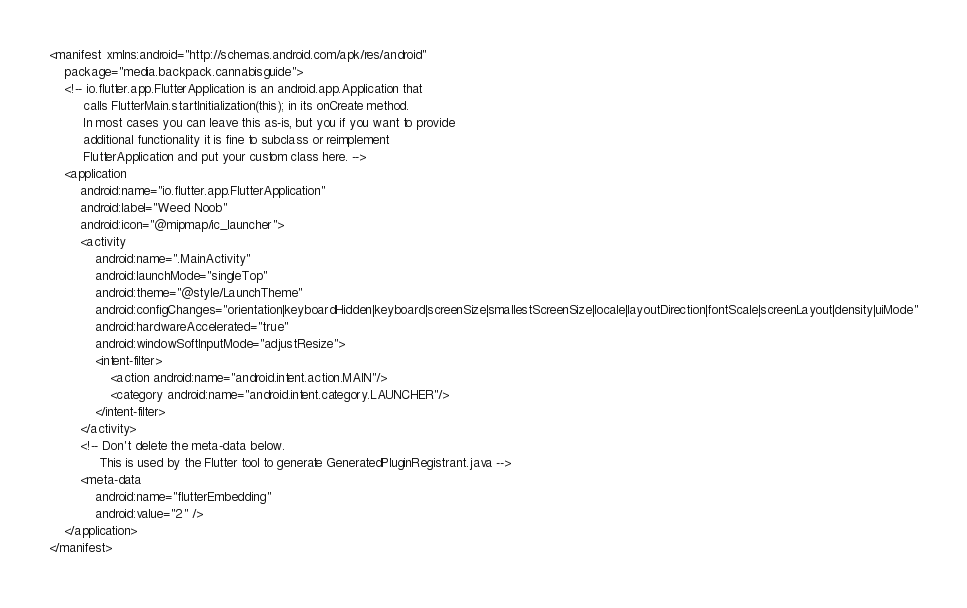Convert code to text. <code><loc_0><loc_0><loc_500><loc_500><_XML_><manifest xmlns:android="http://schemas.android.com/apk/res/android"
    package="media.backpack.cannabisguide">
    <!-- io.flutter.app.FlutterApplication is an android.app.Application that
         calls FlutterMain.startInitialization(this); in its onCreate method.
         In most cases you can leave this as-is, but you if you want to provide
         additional functionality it is fine to subclass or reimplement
         FlutterApplication and put your custom class here. -->
    <application
        android:name="io.flutter.app.FlutterApplication"
        android:label="Weed Noob"
        android:icon="@mipmap/ic_launcher">
        <activity
            android:name=".MainActivity"
            android:launchMode="singleTop"
            android:theme="@style/LaunchTheme"
            android:configChanges="orientation|keyboardHidden|keyboard|screenSize|smallestScreenSize|locale|layoutDirection|fontScale|screenLayout|density|uiMode"
            android:hardwareAccelerated="true"
            android:windowSoftInputMode="adjustResize">
            <intent-filter>
                <action android:name="android.intent.action.MAIN"/>
                <category android:name="android.intent.category.LAUNCHER"/>
            </intent-filter>
        </activity>
        <!-- Don't delete the meta-data below.
             This is used by the Flutter tool to generate GeneratedPluginRegistrant.java -->
        <meta-data
            android:name="flutterEmbedding"
            android:value="2" />
    </application>
</manifest>
</code> 